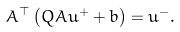Convert formula to latex. <formula><loc_0><loc_0><loc_500><loc_500>A ^ { \top } \left ( Q A u ^ { + } + b \right ) = u ^ { - } .</formula> 